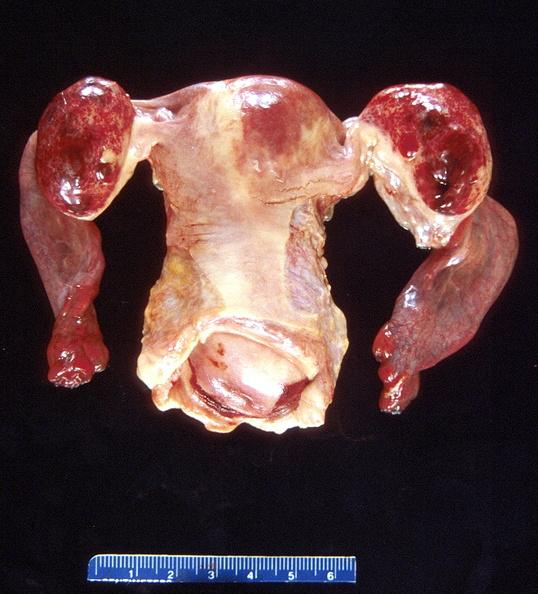where does this part belong to?
Answer the question using a single word or phrase. Female reproductive system 